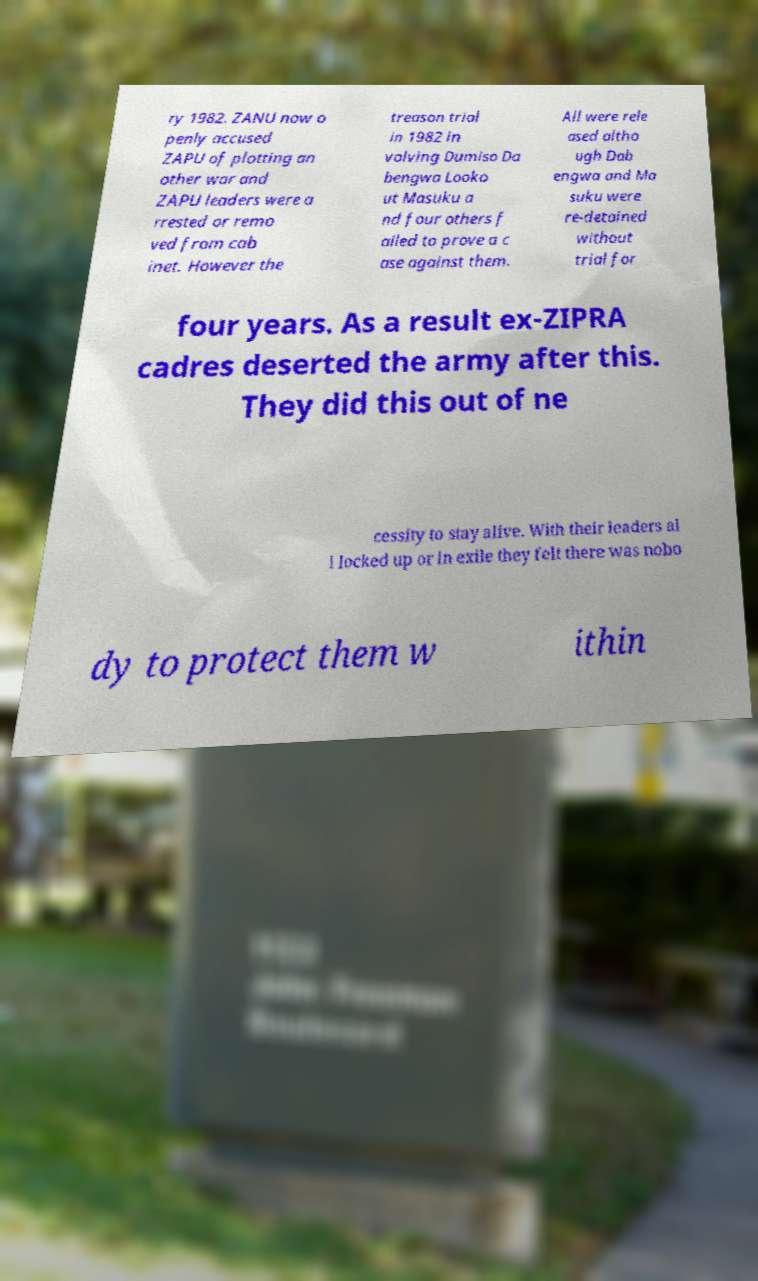Could you assist in decoding the text presented in this image and type it out clearly? ry 1982. ZANU now o penly accused ZAPU of plotting an other war and ZAPU leaders were a rrested or remo ved from cab inet. However the treason trial in 1982 in volving Dumiso Da bengwa Looko ut Masuku a nd four others f ailed to prove a c ase against them. All were rele ased altho ugh Dab engwa and Ma suku were re-detained without trial for four years. As a result ex-ZIPRA cadres deserted the army after this. They did this out of ne cessity to stay alive. With their leaders al l locked up or in exile they felt there was nobo dy to protect them w ithin 